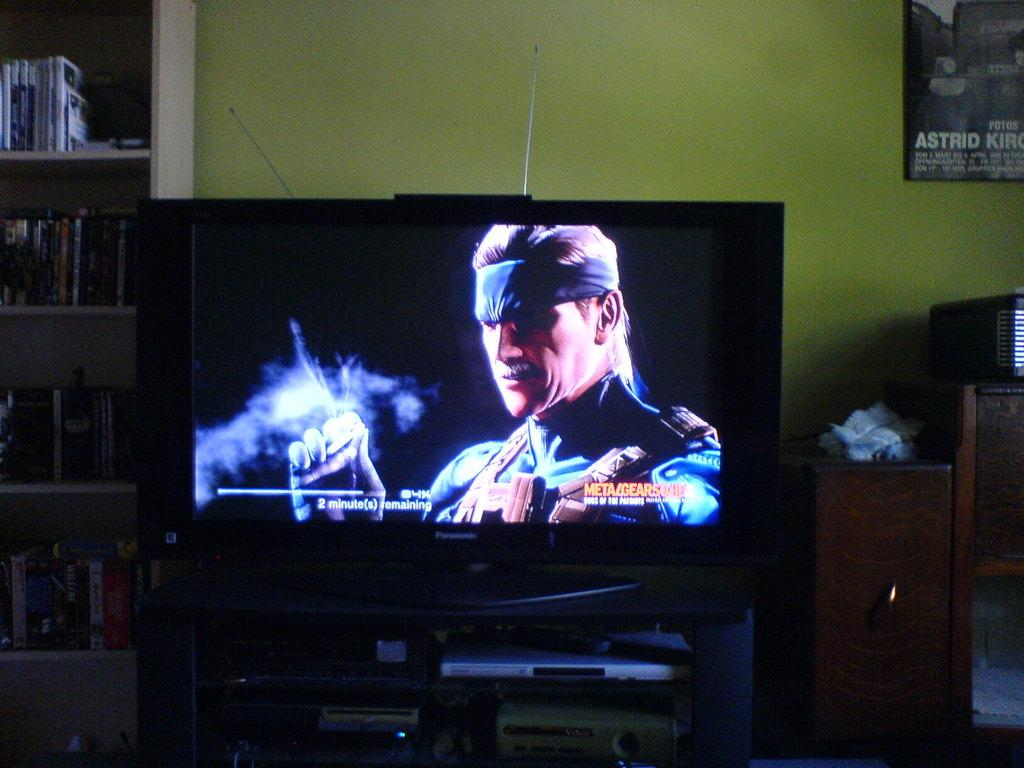Provide a one-sentence caption for the provided image. a television monitor paused on a video game near a poster with the word Astrid on it. 